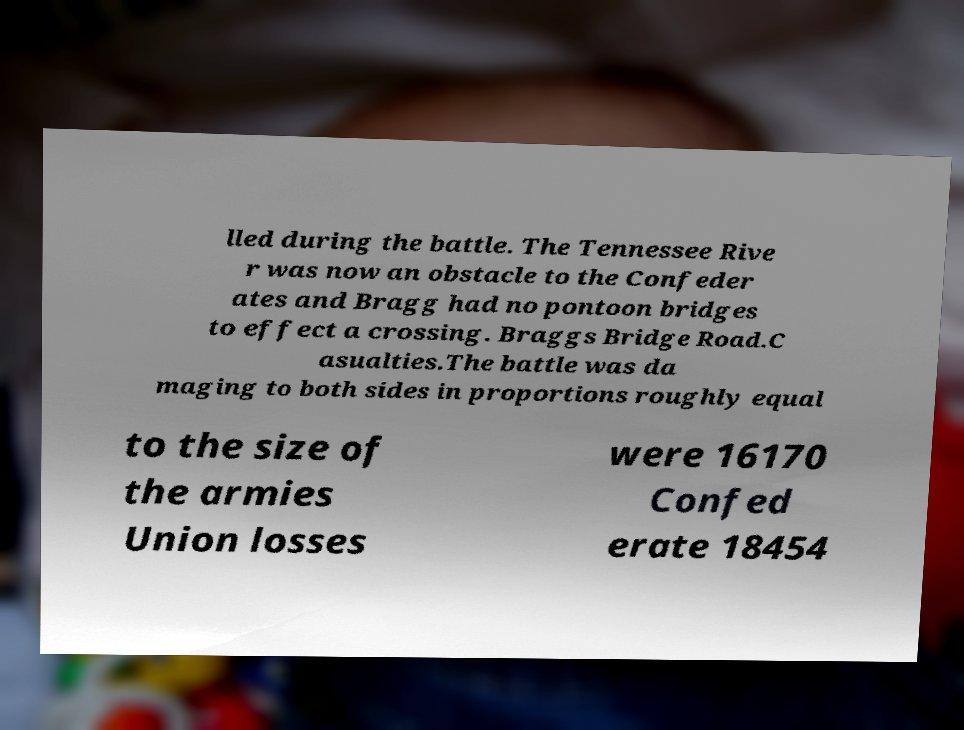Could you assist in decoding the text presented in this image and type it out clearly? lled during the battle. The Tennessee Rive r was now an obstacle to the Confeder ates and Bragg had no pontoon bridges to effect a crossing. Braggs Bridge Road.C asualties.The battle was da maging to both sides in proportions roughly equal to the size of the armies Union losses were 16170 Confed erate 18454 